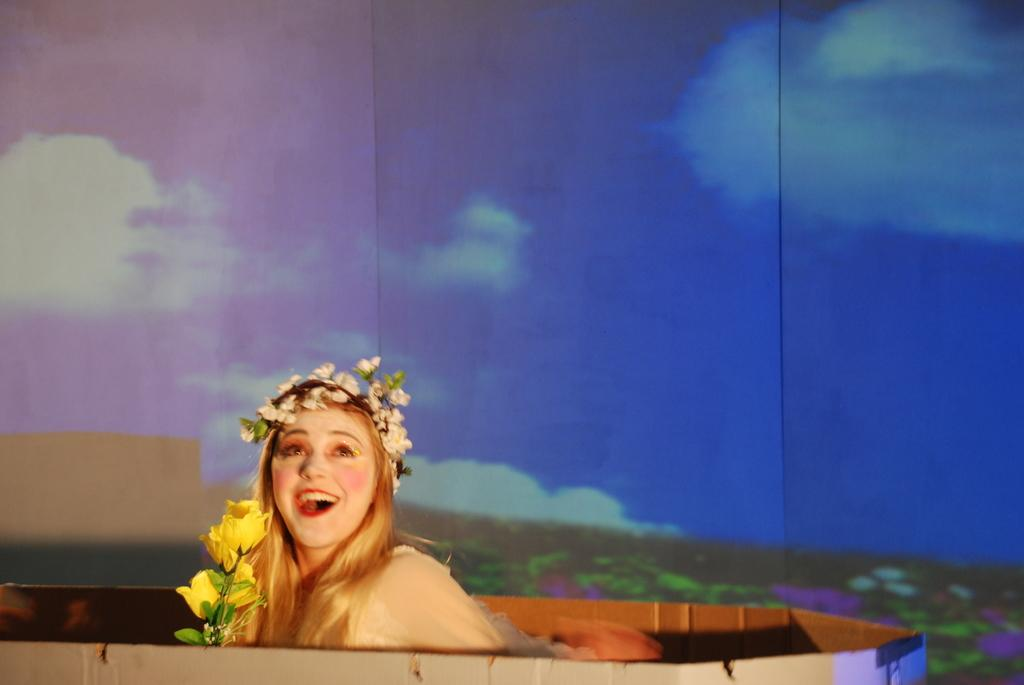Who is present in the image? There is a woman in the image. What is the woman doing in the image? The woman is smiling in the image. What is the woman wearing on her head? The woman is wearing a crown in the image. What is in front of the woman in the image? There are flowers in front of the woman in the image. What can be seen in the background of the image? There are clouds and the sky visible in the background of the image. What type of shirt is the kite wearing in the image? There is no kite present in the image, and therefore no shirt or kite can be observed. 